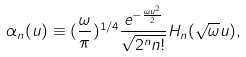<formula> <loc_0><loc_0><loc_500><loc_500>\alpha _ { n } ( u ) \equiv ( \frac { \omega } { \pi } ) ^ { 1 / 4 } \frac { e ^ { - \frac { \omega u ^ { 2 } } 2 } } { \sqrt { 2 ^ { n } n ! } } H _ { n } ( \sqrt { \omega } u ) ,</formula> 